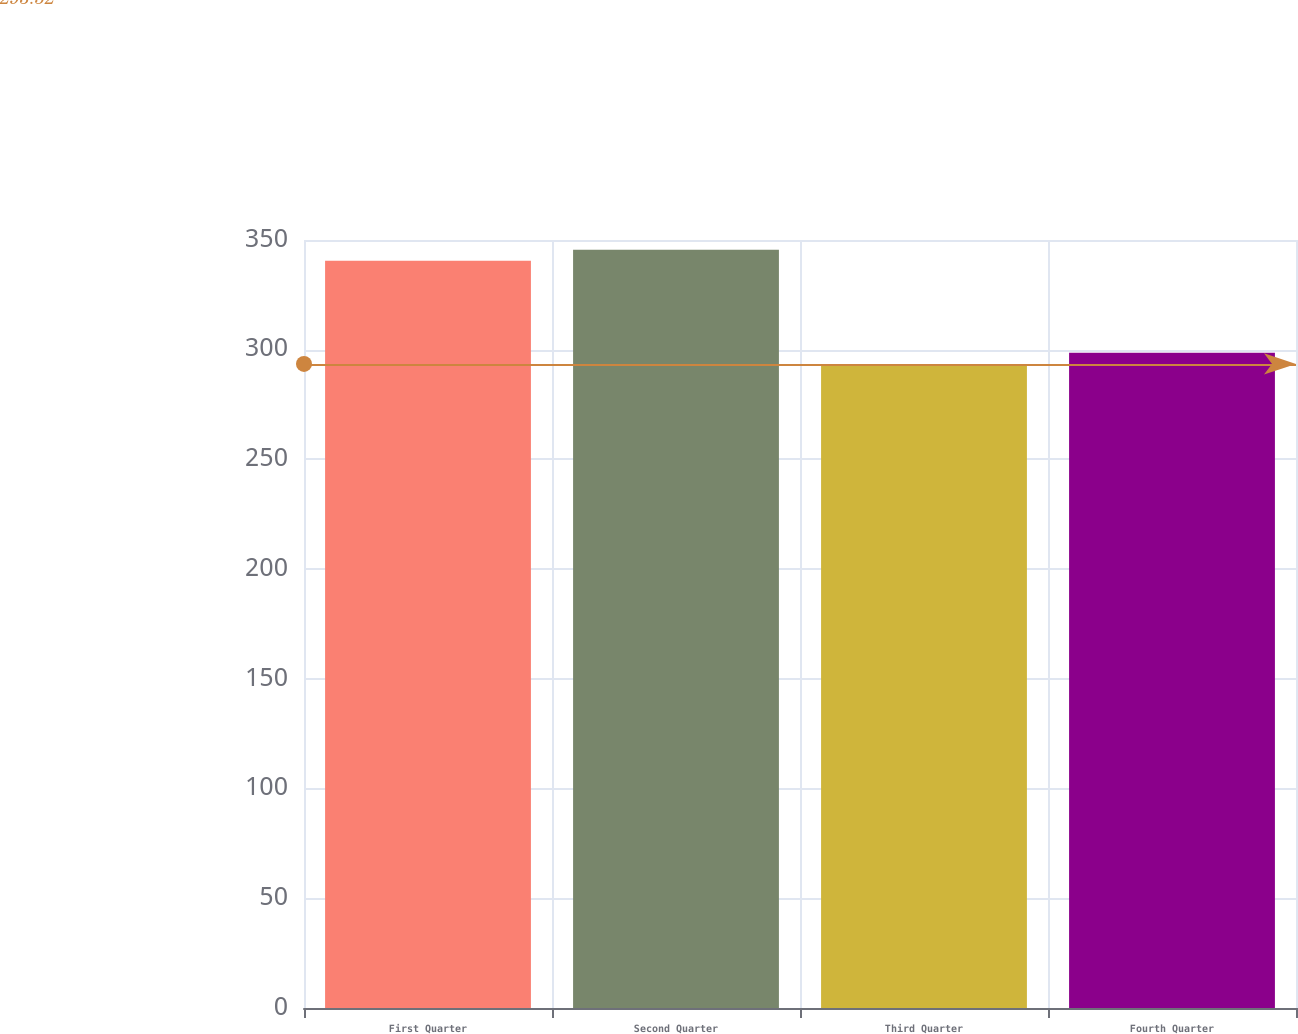<chart> <loc_0><loc_0><loc_500><loc_500><bar_chart><fcel>First Quarter<fcel>Second Quarter<fcel>Third Quarter<fcel>Fourth Quarter<nl><fcel>340.51<fcel>345.61<fcel>293.52<fcel>298.62<nl></chart> 